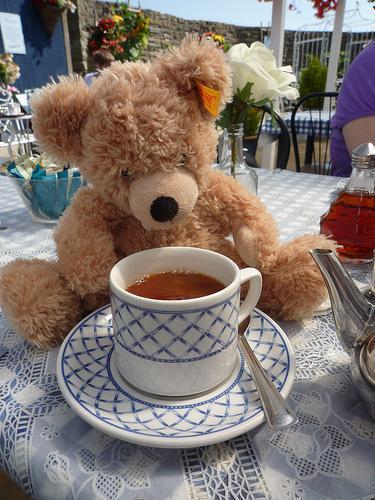How many mugs are shown?
Give a very brief answer. 1. 